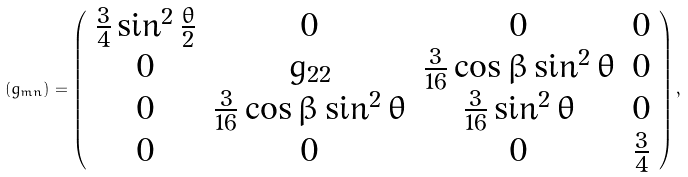<formula> <loc_0><loc_0><loc_500><loc_500>( g _ { m n } ) = \left ( \begin{array} { c c c c } \frac { 3 } { 4 } \sin ^ { 2 } \frac { \theta } { 2 } & 0 & 0 & 0 \\ 0 & g _ { 2 2 } & \frac { 3 } { 1 6 } \cos { \beta } \sin ^ { 2 } \theta & 0 \\ 0 & \frac { 3 } { 1 6 } \cos { \beta } \sin ^ { 2 } \theta & \frac { 3 } { 1 6 } \sin ^ { 2 } \theta & 0 \\ 0 & 0 & 0 & \frac { 3 } { 4 } \\ \end{array} \right ) ,</formula> 